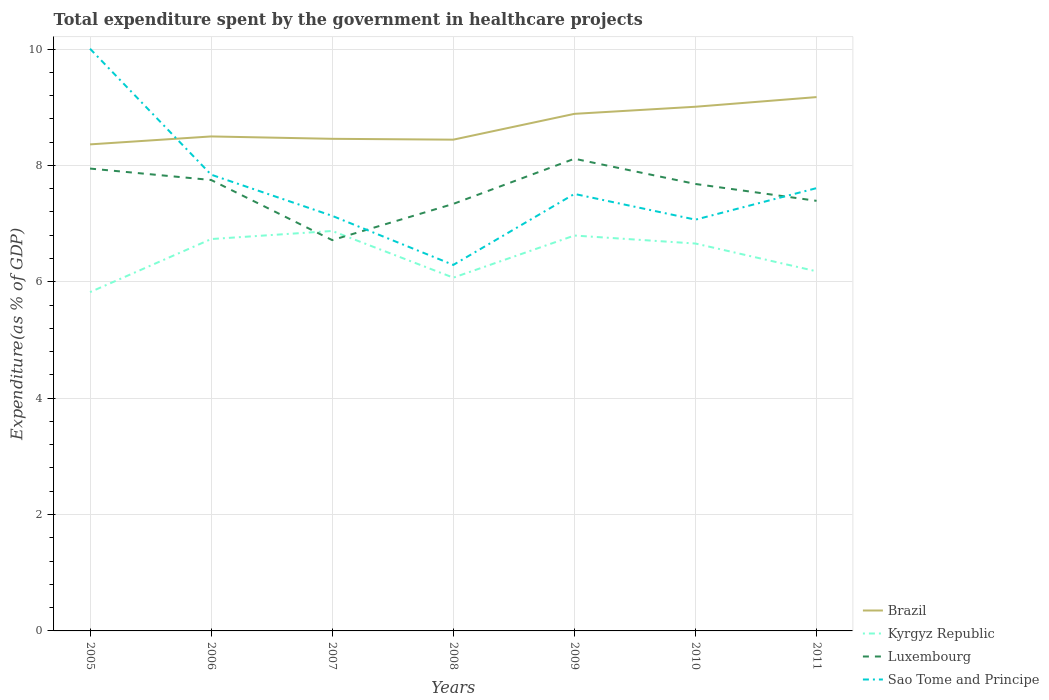Is the number of lines equal to the number of legend labels?
Offer a very short reply. Yes. Across all years, what is the maximum total expenditure spent by the government in healthcare projects in Brazil?
Offer a very short reply. 8.36. What is the total total expenditure spent by the government in healthcare projects in Luxembourg in the graph?
Make the answer very short. -0.34. What is the difference between the highest and the second highest total expenditure spent by the government in healthcare projects in Brazil?
Your answer should be compact. 0.81. What is the difference between the highest and the lowest total expenditure spent by the government in healthcare projects in Brazil?
Provide a succinct answer. 3. How many years are there in the graph?
Keep it short and to the point. 7. What is the difference between two consecutive major ticks on the Y-axis?
Offer a terse response. 2. Where does the legend appear in the graph?
Your answer should be very brief. Bottom right. How many legend labels are there?
Provide a succinct answer. 4. How are the legend labels stacked?
Provide a short and direct response. Vertical. What is the title of the graph?
Provide a short and direct response. Total expenditure spent by the government in healthcare projects. Does "Uzbekistan" appear as one of the legend labels in the graph?
Offer a very short reply. No. What is the label or title of the X-axis?
Ensure brevity in your answer.  Years. What is the label or title of the Y-axis?
Ensure brevity in your answer.  Expenditure(as % of GDP). What is the Expenditure(as % of GDP) of Brazil in 2005?
Offer a very short reply. 8.36. What is the Expenditure(as % of GDP) of Kyrgyz Republic in 2005?
Your response must be concise. 5.82. What is the Expenditure(as % of GDP) of Luxembourg in 2005?
Your answer should be compact. 7.95. What is the Expenditure(as % of GDP) in Sao Tome and Principe in 2005?
Keep it short and to the point. 10. What is the Expenditure(as % of GDP) of Brazil in 2006?
Your answer should be very brief. 8.5. What is the Expenditure(as % of GDP) in Kyrgyz Republic in 2006?
Make the answer very short. 6.73. What is the Expenditure(as % of GDP) of Luxembourg in 2006?
Offer a very short reply. 7.75. What is the Expenditure(as % of GDP) of Sao Tome and Principe in 2006?
Your response must be concise. 7.84. What is the Expenditure(as % of GDP) in Brazil in 2007?
Give a very brief answer. 8.46. What is the Expenditure(as % of GDP) of Kyrgyz Republic in 2007?
Ensure brevity in your answer.  6.87. What is the Expenditure(as % of GDP) of Luxembourg in 2007?
Offer a very short reply. 6.72. What is the Expenditure(as % of GDP) of Sao Tome and Principe in 2007?
Your answer should be compact. 7.13. What is the Expenditure(as % of GDP) of Brazil in 2008?
Provide a short and direct response. 8.44. What is the Expenditure(as % of GDP) of Kyrgyz Republic in 2008?
Offer a terse response. 6.07. What is the Expenditure(as % of GDP) of Luxembourg in 2008?
Offer a very short reply. 7.34. What is the Expenditure(as % of GDP) of Sao Tome and Principe in 2008?
Your answer should be very brief. 6.29. What is the Expenditure(as % of GDP) of Brazil in 2009?
Provide a short and direct response. 8.89. What is the Expenditure(as % of GDP) in Kyrgyz Republic in 2009?
Give a very brief answer. 6.79. What is the Expenditure(as % of GDP) of Luxembourg in 2009?
Keep it short and to the point. 8.11. What is the Expenditure(as % of GDP) of Sao Tome and Principe in 2009?
Give a very brief answer. 7.51. What is the Expenditure(as % of GDP) in Brazil in 2010?
Give a very brief answer. 9.01. What is the Expenditure(as % of GDP) of Kyrgyz Republic in 2010?
Offer a terse response. 6.66. What is the Expenditure(as % of GDP) of Luxembourg in 2010?
Give a very brief answer. 7.68. What is the Expenditure(as % of GDP) of Sao Tome and Principe in 2010?
Your response must be concise. 7.07. What is the Expenditure(as % of GDP) of Brazil in 2011?
Provide a succinct answer. 9.17. What is the Expenditure(as % of GDP) of Kyrgyz Republic in 2011?
Give a very brief answer. 6.18. What is the Expenditure(as % of GDP) of Luxembourg in 2011?
Your response must be concise. 7.39. What is the Expenditure(as % of GDP) of Sao Tome and Principe in 2011?
Make the answer very short. 7.61. Across all years, what is the maximum Expenditure(as % of GDP) in Brazil?
Offer a terse response. 9.17. Across all years, what is the maximum Expenditure(as % of GDP) in Kyrgyz Republic?
Your response must be concise. 6.87. Across all years, what is the maximum Expenditure(as % of GDP) in Luxembourg?
Make the answer very short. 8.11. Across all years, what is the maximum Expenditure(as % of GDP) in Sao Tome and Principe?
Your answer should be very brief. 10. Across all years, what is the minimum Expenditure(as % of GDP) in Brazil?
Make the answer very short. 8.36. Across all years, what is the minimum Expenditure(as % of GDP) in Kyrgyz Republic?
Your answer should be compact. 5.82. Across all years, what is the minimum Expenditure(as % of GDP) in Luxembourg?
Make the answer very short. 6.72. Across all years, what is the minimum Expenditure(as % of GDP) in Sao Tome and Principe?
Offer a terse response. 6.29. What is the total Expenditure(as % of GDP) in Brazil in the graph?
Offer a terse response. 60.83. What is the total Expenditure(as % of GDP) of Kyrgyz Republic in the graph?
Ensure brevity in your answer.  45.13. What is the total Expenditure(as % of GDP) in Luxembourg in the graph?
Your answer should be compact. 52.94. What is the total Expenditure(as % of GDP) of Sao Tome and Principe in the graph?
Offer a terse response. 53.46. What is the difference between the Expenditure(as % of GDP) of Brazil in 2005 and that in 2006?
Provide a short and direct response. -0.14. What is the difference between the Expenditure(as % of GDP) in Kyrgyz Republic in 2005 and that in 2006?
Ensure brevity in your answer.  -0.91. What is the difference between the Expenditure(as % of GDP) in Luxembourg in 2005 and that in 2006?
Your answer should be compact. 0.2. What is the difference between the Expenditure(as % of GDP) of Sao Tome and Principe in 2005 and that in 2006?
Offer a very short reply. 2.16. What is the difference between the Expenditure(as % of GDP) of Brazil in 2005 and that in 2007?
Ensure brevity in your answer.  -0.1. What is the difference between the Expenditure(as % of GDP) of Kyrgyz Republic in 2005 and that in 2007?
Offer a very short reply. -1.05. What is the difference between the Expenditure(as % of GDP) of Luxembourg in 2005 and that in 2007?
Offer a very short reply. 1.23. What is the difference between the Expenditure(as % of GDP) in Sao Tome and Principe in 2005 and that in 2007?
Provide a short and direct response. 2.87. What is the difference between the Expenditure(as % of GDP) in Brazil in 2005 and that in 2008?
Ensure brevity in your answer.  -0.08. What is the difference between the Expenditure(as % of GDP) of Kyrgyz Republic in 2005 and that in 2008?
Offer a very short reply. -0.25. What is the difference between the Expenditure(as % of GDP) of Luxembourg in 2005 and that in 2008?
Offer a very short reply. 0.61. What is the difference between the Expenditure(as % of GDP) of Sao Tome and Principe in 2005 and that in 2008?
Offer a very short reply. 3.71. What is the difference between the Expenditure(as % of GDP) in Brazil in 2005 and that in 2009?
Provide a short and direct response. -0.52. What is the difference between the Expenditure(as % of GDP) of Kyrgyz Republic in 2005 and that in 2009?
Your answer should be very brief. -0.97. What is the difference between the Expenditure(as % of GDP) of Luxembourg in 2005 and that in 2009?
Provide a short and direct response. -0.17. What is the difference between the Expenditure(as % of GDP) in Sao Tome and Principe in 2005 and that in 2009?
Offer a very short reply. 2.5. What is the difference between the Expenditure(as % of GDP) of Brazil in 2005 and that in 2010?
Offer a terse response. -0.65. What is the difference between the Expenditure(as % of GDP) of Kyrgyz Republic in 2005 and that in 2010?
Provide a short and direct response. -0.83. What is the difference between the Expenditure(as % of GDP) in Luxembourg in 2005 and that in 2010?
Your answer should be very brief. 0.26. What is the difference between the Expenditure(as % of GDP) in Sao Tome and Principe in 2005 and that in 2010?
Your answer should be very brief. 2.94. What is the difference between the Expenditure(as % of GDP) in Brazil in 2005 and that in 2011?
Provide a succinct answer. -0.81. What is the difference between the Expenditure(as % of GDP) of Kyrgyz Republic in 2005 and that in 2011?
Make the answer very short. -0.36. What is the difference between the Expenditure(as % of GDP) in Luxembourg in 2005 and that in 2011?
Provide a succinct answer. 0.55. What is the difference between the Expenditure(as % of GDP) in Sao Tome and Principe in 2005 and that in 2011?
Keep it short and to the point. 2.4. What is the difference between the Expenditure(as % of GDP) in Brazil in 2006 and that in 2007?
Make the answer very short. 0.04. What is the difference between the Expenditure(as % of GDP) in Kyrgyz Republic in 2006 and that in 2007?
Make the answer very short. -0.14. What is the difference between the Expenditure(as % of GDP) in Luxembourg in 2006 and that in 2007?
Offer a very short reply. 1.03. What is the difference between the Expenditure(as % of GDP) of Sao Tome and Principe in 2006 and that in 2007?
Provide a succinct answer. 0.71. What is the difference between the Expenditure(as % of GDP) in Brazil in 2006 and that in 2008?
Keep it short and to the point. 0.06. What is the difference between the Expenditure(as % of GDP) in Kyrgyz Republic in 2006 and that in 2008?
Provide a succinct answer. 0.66. What is the difference between the Expenditure(as % of GDP) in Luxembourg in 2006 and that in 2008?
Your answer should be very brief. 0.41. What is the difference between the Expenditure(as % of GDP) of Sao Tome and Principe in 2006 and that in 2008?
Your response must be concise. 1.55. What is the difference between the Expenditure(as % of GDP) in Brazil in 2006 and that in 2009?
Provide a succinct answer. -0.39. What is the difference between the Expenditure(as % of GDP) of Kyrgyz Republic in 2006 and that in 2009?
Your answer should be very brief. -0.06. What is the difference between the Expenditure(as % of GDP) of Luxembourg in 2006 and that in 2009?
Make the answer very short. -0.37. What is the difference between the Expenditure(as % of GDP) in Sao Tome and Principe in 2006 and that in 2009?
Provide a succinct answer. 0.33. What is the difference between the Expenditure(as % of GDP) of Brazil in 2006 and that in 2010?
Make the answer very short. -0.51. What is the difference between the Expenditure(as % of GDP) in Kyrgyz Republic in 2006 and that in 2010?
Ensure brevity in your answer.  0.08. What is the difference between the Expenditure(as % of GDP) of Luxembourg in 2006 and that in 2010?
Offer a terse response. 0.07. What is the difference between the Expenditure(as % of GDP) in Sao Tome and Principe in 2006 and that in 2010?
Your answer should be very brief. 0.77. What is the difference between the Expenditure(as % of GDP) in Brazil in 2006 and that in 2011?
Ensure brevity in your answer.  -0.68. What is the difference between the Expenditure(as % of GDP) in Kyrgyz Republic in 2006 and that in 2011?
Ensure brevity in your answer.  0.55. What is the difference between the Expenditure(as % of GDP) of Luxembourg in 2006 and that in 2011?
Offer a terse response. 0.36. What is the difference between the Expenditure(as % of GDP) of Sao Tome and Principe in 2006 and that in 2011?
Make the answer very short. 0.23. What is the difference between the Expenditure(as % of GDP) of Brazil in 2007 and that in 2008?
Provide a short and direct response. 0.01. What is the difference between the Expenditure(as % of GDP) of Kyrgyz Republic in 2007 and that in 2008?
Offer a very short reply. 0.8. What is the difference between the Expenditure(as % of GDP) of Luxembourg in 2007 and that in 2008?
Your answer should be very brief. -0.62. What is the difference between the Expenditure(as % of GDP) of Sao Tome and Principe in 2007 and that in 2008?
Keep it short and to the point. 0.84. What is the difference between the Expenditure(as % of GDP) of Brazil in 2007 and that in 2009?
Your answer should be compact. -0.43. What is the difference between the Expenditure(as % of GDP) in Kyrgyz Republic in 2007 and that in 2009?
Offer a very short reply. 0.08. What is the difference between the Expenditure(as % of GDP) in Luxembourg in 2007 and that in 2009?
Ensure brevity in your answer.  -1.4. What is the difference between the Expenditure(as % of GDP) of Sao Tome and Principe in 2007 and that in 2009?
Your answer should be compact. -0.38. What is the difference between the Expenditure(as % of GDP) in Brazil in 2007 and that in 2010?
Give a very brief answer. -0.55. What is the difference between the Expenditure(as % of GDP) in Kyrgyz Republic in 2007 and that in 2010?
Provide a succinct answer. 0.22. What is the difference between the Expenditure(as % of GDP) in Luxembourg in 2007 and that in 2010?
Make the answer very short. -0.96. What is the difference between the Expenditure(as % of GDP) of Sao Tome and Principe in 2007 and that in 2010?
Your answer should be very brief. 0.07. What is the difference between the Expenditure(as % of GDP) of Brazil in 2007 and that in 2011?
Make the answer very short. -0.72. What is the difference between the Expenditure(as % of GDP) in Kyrgyz Republic in 2007 and that in 2011?
Your answer should be compact. 0.69. What is the difference between the Expenditure(as % of GDP) of Luxembourg in 2007 and that in 2011?
Offer a very short reply. -0.68. What is the difference between the Expenditure(as % of GDP) of Sao Tome and Principe in 2007 and that in 2011?
Your answer should be very brief. -0.48. What is the difference between the Expenditure(as % of GDP) in Brazil in 2008 and that in 2009?
Your answer should be compact. -0.44. What is the difference between the Expenditure(as % of GDP) in Kyrgyz Republic in 2008 and that in 2009?
Provide a succinct answer. -0.72. What is the difference between the Expenditure(as % of GDP) in Luxembourg in 2008 and that in 2009?
Keep it short and to the point. -0.78. What is the difference between the Expenditure(as % of GDP) in Sao Tome and Principe in 2008 and that in 2009?
Provide a succinct answer. -1.22. What is the difference between the Expenditure(as % of GDP) of Brazil in 2008 and that in 2010?
Your response must be concise. -0.57. What is the difference between the Expenditure(as % of GDP) of Kyrgyz Republic in 2008 and that in 2010?
Keep it short and to the point. -0.59. What is the difference between the Expenditure(as % of GDP) of Luxembourg in 2008 and that in 2010?
Ensure brevity in your answer.  -0.34. What is the difference between the Expenditure(as % of GDP) in Sao Tome and Principe in 2008 and that in 2010?
Offer a terse response. -0.78. What is the difference between the Expenditure(as % of GDP) in Brazil in 2008 and that in 2011?
Give a very brief answer. -0.73. What is the difference between the Expenditure(as % of GDP) of Kyrgyz Republic in 2008 and that in 2011?
Your answer should be compact. -0.11. What is the difference between the Expenditure(as % of GDP) of Luxembourg in 2008 and that in 2011?
Ensure brevity in your answer.  -0.05. What is the difference between the Expenditure(as % of GDP) in Sao Tome and Principe in 2008 and that in 2011?
Ensure brevity in your answer.  -1.32. What is the difference between the Expenditure(as % of GDP) in Brazil in 2009 and that in 2010?
Your answer should be very brief. -0.12. What is the difference between the Expenditure(as % of GDP) of Kyrgyz Republic in 2009 and that in 2010?
Your answer should be very brief. 0.14. What is the difference between the Expenditure(as % of GDP) of Luxembourg in 2009 and that in 2010?
Provide a succinct answer. 0.43. What is the difference between the Expenditure(as % of GDP) of Sao Tome and Principe in 2009 and that in 2010?
Offer a very short reply. 0.44. What is the difference between the Expenditure(as % of GDP) of Brazil in 2009 and that in 2011?
Your answer should be compact. -0.29. What is the difference between the Expenditure(as % of GDP) of Kyrgyz Republic in 2009 and that in 2011?
Provide a short and direct response. 0.62. What is the difference between the Expenditure(as % of GDP) of Luxembourg in 2009 and that in 2011?
Your response must be concise. 0.72. What is the difference between the Expenditure(as % of GDP) of Sao Tome and Principe in 2009 and that in 2011?
Offer a very short reply. -0.1. What is the difference between the Expenditure(as % of GDP) of Brazil in 2010 and that in 2011?
Provide a short and direct response. -0.17. What is the difference between the Expenditure(as % of GDP) in Kyrgyz Republic in 2010 and that in 2011?
Give a very brief answer. 0.48. What is the difference between the Expenditure(as % of GDP) in Luxembourg in 2010 and that in 2011?
Offer a terse response. 0.29. What is the difference between the Expenditure(as % of GDP) of Sao Tome and Principe in 2010 and that in 2011?
Your answer should be very brief. -0.54. What is the difference between the Expenditure(as % of GDP) in Brazil in 2005 and the Expenditure(as % of GDP) in Kyrgyz Republic in 2006?
Give a very brief answer. 1.63. What is the difference between the Expenditure(as % of GDP) of Brazil in 2005 and the Expenditure(as % of GDP) of Luxembourg in 2006?
Ensure brevity in your answer.  0.61. What is the difference between the Expenditure(as % of GDP) of Brazil in 2005 and the Expenditure(as % of GDP) of Sao Tome and Principe in 2006?
Provide a short and direct response. 0.52. What is the difference between the Expenditure(as % of GDP) in Kyrgyz Republic in 2005 and the Expenditure(as % of GDP) in Luxembourg in 2006?
Your answer should be compact. -1.93. What is the difference between the Expenditure(as % of GDP) of Kyrgyz Republic in 2005 and the Expenditure(as % of GDP) of Sao Tome and Principe in 2006?
Make the answer very short. -2.02. What is the difference between the Expenditure(as % of GDP) of Luxembourg in 2005 and the Expenditure(as % of GDP) of Sao Tome and Principe in 2006?
Give a very brief answer. 0.1. What is the difference between the Expenditure(as % of GDP) of Brazil in 2005 and the Expenditure(as % of GDP) of Kyrgyz Republic in 2007?
Give a very brief answer. 1.49. What is the difference between the Expenditure(as % of GDP) in Brazil in 2005 and the Expenditure(as % of GDP) in Luxembourg in 2007?
Your answer should be very brief. 1.65. What is the difference between the Expenditure(as % of GDP) in Brazil in 2005 and the Expenditure(as % of GDP) in Sao Tome and Principe in 2007?
Offer a terse response. 1.23. What is the difference between the Expenditure(as % of GDP) of Kyrgyz Republic in 2005 and the Expenditure(as % of GDP) of Luxembourg in 2007?
Your response must be concise. -0.89. What is the difference between the Expenditure(as % of GDP) in Kyrgyz Republic in 2005 and the Expenditure(as % of GDP) in Sao Tome and Principe in 2007?
Your response must be concise. -1.31. What is the difference between the Expenditure(as % of GDP) of Luxembourg in 2005 and the Expenditure(as % of GDP) of Sao Tome and Principe in 2007?
Keep it short and to the point. 0.81. What is the difference between the Expenditure(as % of GDP) of Brazil in 2005 and the Expenditure(as % of GDP) of Kyrgyz Republic in 2008?
Keep it short and to the point. 2.29. What is the difference between the Expenditure(as % of GDP) in Brazil in 2005 and the Expenditure(as % of GDP) in Luxembourg in 2008?
Give a very brief answer. 1.02. What is the difference between the Expenditure(as % of GDP) of Brazil in 2005 and the Expenditure(as % of GDP) of Sao Tome and Principe in 2008?
Your answer should be very brief. 2.07. What is the difference between the Expenditure(as % of GDP) of Kyrgyz Republic in 2005 and the Expenditure(as % of GDP) of Luxembourg in 2008?
Ensure brevity in your answer.  -1.52. What is the difference between the Expenditure(as % of GDP) in Kyrgyz Republic in 2005 and the Expenditure(as % of GDP) in Sao Tome and Principe in 2008?
Make the answer very short. -0.47. What is the difference between the Expenditure(as % of GDP) in Luxembourg in 2005 and the Expenditure(as % of GDP) in Sao Tome and Principe in 2008?
Provide a short and direct response. 1.66. What is the difference between the Expenditure(as % of GDP) of Brazil in 2005 and the Expenditure(as % of GDP) of Kyrgyz Republic in 2009?
Ensure brevity in your answer.  1.57. What is the difference between the Expenditure(as % of GDP) in Brazil in 2005 and the Expenditure(as % of GDP) in Luxembourg in 2009?
Ensure brevity in your answer.  0.25. What is the difference between the Expenditure(as % of GDP) of Brazil in 2005 and the Expenditure(as % of GDP) of Sao Tome and Principe in 2009?
Keep it short and to the point. 0.85. What is the difference between the Expenditure(as % of GDP) in Kyrgyz Republic in 2005 and the Expenditure(as % of GDP) in Luxembourg in 2009?
Your answer should be very brief. -2.29. What is the difference between the Expenditure(as % of GDP) in Kyrgyz Republic in 2005 and the Expenditure(as % of GDP) in Sao Tome and Principe in 2009?
Offer a very short reply. -1.69. What is the difference between the Expenditure(as % of GDP) of Luxembourg in 2005 and the Expenditure(as % of GDP) of Sao Tome and Principe in 2009?
Ensure brevity in your answer.  0.44. What is the difference between the Expenditure(as % of GDP) of Brazil in 2005 and the Expenditure(as % of GDP) of Kyrgyz Republic in 2010?
Your answer should be compact. 1.7. What is the difference between the Expenditure(as % of GDP) of Brazil in 2005 and the Expenditure(as % of GDP) of Luxembourg in 2010?
Keep it short and to the point. 0.68. What is the difference between the Expenditure(as % of GDP) in Brazil in 2005 and the Expenditure(as % of GDP) in Sao Tome and Principe in 2010?
Your answer should be very brief. 1.29. What is the difference between the Expenditure(as % of GDP) in Kyrgyz Republic in 2005 and the Expenditure(as % of GDP) in Luxembourg in 2010?
Keep it short and to the point. -1.86. What is the difference between the Expenditure(as % of GDP) of Kyrgyz Republic in 2005 and the Expenditure(as % of GDP) of Sao Tome and Principe in 2010?
Make the answer very short. -1.25. What is the difference between the Expenditure(as % of GDP) of Luxembourg in 2005 and the Expenditure(as % of GDP) of Sao Tome and Principe in 2010?
Give a very brief answer. 0.88. What is the difference between the Expenditure(as % of GDP) in Brazil in 2005 and the Expenditure(as % of GDP) in Kyrgyz Republic in 2011?
Provide a short and direct response. 2.18. What is the difference between the Expenditure(as % of GDP) of Brazil in 2005 and the Expenditure(as % of GDP) of Luxembourg in 2011?
Provide a short and direct response. 0.97. What is the difference between the Expenditure(as % of GDP) of Brazil in 2005 and the Expenditure(as % of GDP) of Sao Tome and Principe in 2011?
Provide a short and direct response. 0.75. What is the difference between the Expenditure(as % of GDP) of Kyrgyz Republic in 2005 and the Expenditure(as % of GDP) of Luxembourg in 2011?
Provide a succinct answer. -1.57. What is the difference between the Expenditure(as % of GDP) of Kyrgyz Republic in 2005 and the Expenditure(as % of GDP) of Sao Tome and Principe in 2011?
Offer a terse response. -1.79. What is the difference between the Expenditure(as % of GDP) of Luxembourg in 2005 and the Expenditure(as % of GDP) of Sao Tome and Principe in 2011?
Your answer should be compact. 0.34. What is the difference between the Expenditure(as % of GDP) of Brazil in 2006 and the Expenditure(as % of GDP) of Kyrgyz Republic in 2007?
Provide a succinct answer. 1.62. What is the difference between the Expenditure(as % of GDP) of Brazil in 2006 and the Expenditure(as % of GDP) of Luxembourg in 2007?
Offer a terse response. 1.78. What is the difference between the Expenditure(as % of GDP) of Brazil in 2006 and the Expenditure(as % of GDP) of Sao Tome and Principe in 2007?
Give a very brief answer. 1.36. What is the difference between the Expenditure(as % of GDP) of Kyrgyz Republic in 2006 and the Expenditure(as % of GDP) of Luxembourg in 2007?
Give a very brief answer. 0.02. What is the difference between the Expenditure(as % of GDP) in Kyrgyz Republic in 2006 and the Expenditure(as % of GDP) in Sao Tome and Principe in 2007?
Offer a very short reply. -0.4. What is the difference between the Expenditure(as % of GDP) in Luxembourg in 2006 and the Expenditure(as % of GDP) in Sao Tome and Principe in 2007?
Provide a short and direct response. 0.62. What is the difference between the Expenditure(as % of GDP) of Brazil in 2006 and the Expenditure(as % of GDP) of Kyrgyz Republic in 2008?
Give a very brief answer. 2.43. What is the difference between the Expenditure(as % of GDP) of Brazil in 2006 and the Expenditure(as % of GDP) of Luxembourg in 2008?
Your answer should be very brief. 1.16. What is the difference between the Expenditure(as % of GDP) in Brazil in 2006 and the Expenditure(as % of GDP) in Sao Tome and Principe in 2008?
Offer a very short reply. 2.21. What is the difference between the Expenditure(as % of GDP) in Kyrgyz Republic in 2006 and the Expenditure(as % of GDP) in Luxembourg in 2008?
Keep it short and to the point. -0.6. What is the difference between the Expenditure(as % of GDP) in Kyrgyz Republic in 2006 and the Expenditure(as % of GDP) in Sao Tome and Principe in 2008?
Provide a succinct answer. 0.44. What is the difference between the Expenditure(as % of GDP) in Luxembourg in 2006 and the Expenditure(as % of GDP) in Sao Tome and Principe in 2008?
Make the answer very short. 1.46. What is the difference between the Expenditure(as % of GDP) in Brazil in 2006 and the Expenditure(as % of GDP) in Kyrgyz Republic in 2009?
Keep it short and to the point. 1.7. What is the difference between the Expenditure(as % of GDP) in Brazil in 2006 and the Expenditure(as % of GDP) in Luxembourg in 2009?
Make the answer very short. 0.38. What is the difference between the Expenditure(as % of GDP) of Brazil in 2006 and the Expenditure(as % of GDP) of Sao Tome and Principe in 2009?
Your answer should be compact. 0.99. What is the difference between the Expenditure(as % of GDP) of Kyrgyz Republic in 2006 and the Expenditure(as % of GDP) of Luxembourg in 2009?
Make the answer very short. -1.38. What is the difference between the Expenditure(as % of GDP) in Kyrgyz Republic in 2006 and the Expenditure(as % of GDP) in Sao Tome and Principe in 2009?
Ensure brevity in your answer.  -0.78. What is the difference between the Expenditure(as % of GDP) of Luxembourg in 2006 and the Expenditure(as % of GDP) of Sao Tome and Principe in 2009?
Provide a succinct answer. 0.24. What is the difference between the Expenditure(as % of GDP) in Brazil in 2006 and the Expenditure(as % of GDP) in Kyrgyz Republic in 2010?
Make the answer very short. 1.84. What is the difference between the Expenditure(as % of GDP) of Brazil in 2006 and the Expenditure(as % of GDP) of Luxembourg in 2010?
Ensure brevity in your answer.  0.82. What is the difference between the Expenditure(as % of GDP) in Brazil in 2006 and the Expenditure(as % of GDP) in Sao Tome and Principe in 2010?
Offer a terse response. 1.43. What is the difference between the Expenditure(as % of GDP) in Kyrgyz Republic in 2006 and the Expenditure(as % of GDP) in Luxembourg in 2010?
Keep it short and to the point. -0.95. What is the difference between the Expenditure(as % of GDP) of Kyrgyz Republic in 2006 and the Expenditure(as % of GDP) of Sao Tome and Principe in 2010?
Give a very brief answer. -0.33. What is the difference between the Expenditure(as % of GDP) in Luxembourg in 2006 and the Expenditure(as % of GDP) in Sao Tome and Principe in 2010?
Keep it short and to the point. 0.68. What is the difference between the Expenditure(as % of GDP) in Brazil in 2006 and the Expenditure(as % of GDP) in Kyrgyz Republic in 2011?
Provide a succinct answer. 2.32. What is the difference between the Expenditure(as % of GDP) of Brazil in 2006 and the Expenditure(as % of GDP) of Luxembourg in 2011?
Make the answer very short. 1.11. What is the difference between the Expenditure(as % of GDP) in Brazil in 2006 and the Expenditure(as % of GDP) in Sao Tome and Principe in 2011?
Make the answer very short. 0.89. What is the difference between the Expenditure(as % of GDP) in Kyrgyz Republic in 2006 and the Expenditure(as % of GDP) in Luxembourg in 2011?
Ensure brevity in your answer.  -0.66. What is the difference between the Expenditure(as % of GDP) in Kyrgyz Republic in 2006 and the Expenditure(as % of GDP) in Sao Tome and Principe in 2011?
Your answer should be very brief. -0.88. What is the difference between the Expenditure(as % of GDP) in Luxembourg in 2006 and the Expenditure(as % of GDP) in Sao Tome and Principe in 2011?
Your response must be concise. 0.14. What is the difference between the Expenditure(as % of GDP) of Brazil in 2007 and the Expenditure(as % of GDP) of Kyrgyz Republic in 2008?
Keep it short and to the point. 2.39. What is the difference between the Expenditure(as % of GDP) of Brazil in 2007 and the Expenditure(as % of GDP) of Luxembourg in 2008?
Provide a succinct answer. 1.12. What is the difference between the Expenditure(as % of GDP) of Brazil in 2007 and the Expenditure(as % of GDP) of Sao Tome and Principe in 2008?
Offer a very short reply. 2.17. What is the difference between the Expenditure(as % of GDP) of Kyrgyz Republic in 2007 and the Expenditure(as % of GDP) of Luxembourg in 2008?
Your answer should be very brief. -0.47. What is the difference between the Expenditure(as % of GDP) in Kyrgyz Republic in 2007 and the Expenditure(as % of GDP) in Sao Tome and Principe in 2008?
Provide a short and direct response. 0.58. What is the difference between the Expenditure(as % of GDP) in Luxembourg in 2007 and the Expenditure(as % of GDP) in Sao Tome and Principe in 2008?
Provide a succinct answer. 0.43. What is the difference between the Expenditure(as % of GDP) in Brazil in 2007 and the Expenditure(as % of GDP) in Kyrgyz Republic in 2009?
Make the answer very short. 1.66. What is the difference between the Expenditure(as % of GDP) of Brazil in 2007 and the Expenditure(as % of GDP) of Luxembourg in 2009?
Keep it short and to the point. 0.34. What is the difference between the Expenditure(as % of GDP) in Brazil in 2007 and the Expenditure(as % of GDP) in Sao Tome and Principe in 2009?
Your answer should be very brief. 0.95. What is the difference between the Expenditure(as % of GDP) in Kyrgyz Republic in 2007 and the Expenditure(as % of GDP) in Luxembourg in 2009?
Provide a succinct answer. -1.24. What is the difference between the Expenditure(as % of GDP) of Kyrgyz Republic in 2007 and the Expenditure(as % of GDP) of Sao Tome and Principe in 2009?
Provide a short and direct response. -0.64. What is the difference between the Expenditure(as % of GDP) of Luxembourg in 2007 and the Expenditure(as % of GDP) of Sao Tome and Principe in 2009?
Keep it short and to the point. -0.79. What is the difference between the Expenditure(as % of GDP) of Brazil in 2007 and the Expenditure(as % of GDP) of Kyrgyz Republic in 2010?
Make the answer very short. 1.8. What is the difference between the Expenditure(as % of GDP) of Brazil in 2007 and the Expenditure(as % of GDP) of Luxembourg in 2010?
Keep it short and to the point. 0.78. What is the difference between the Expenditure(as % of GDP) of Brazil in 2007 and the Expenditure(as % of GDP) of Sao Tome and Principe in 2010?
Keep it short and to the point. 1.39. What is the difference between the Expenditure(as % of GDP) of Kyrgyz Republic in 2007 and the Expenditure(as % of GDP) of Luxembourg in 2010?
Ensure brevity in your answer.  -0.81. What is the difference between the Expenditure(as % of GDP) in Kyrgyz Republic in 2007 and the Expenditure(as % of GDP) in Sao Tome and Principe in 2010?
Offer a terse response. -0.19. What is the difference between the Expenditure(as % of GDP) in Luxembourg in 2007 and the Expenditure(as % of GDP) in Sao Tome and Principe in 2010?
Your answer should be compact. -0.35. What is the difference between the Expenditure(as % of GDP) of Brazil in 2007 and the Expenditure(as % of GDP) of Kyrgyz Republic in 2011?
Offer a terse response. 2.28. What is the difference between the Expenditure(as % of GDP) of Brazil in 2007 and the Expenditure(as % of GDP) of Luxembourg in 2011?
Ensure brevity in your answer.  1.07. What is the difference between the Expenditure(as % of GDP) in Brazil in 2007 and the Expenditure(as % of GDP) in Sao Tome and Principe in 2011?
Make the answer very short. 0.85. What is the difference between the Expenditure(as % of GDP) in Kyrgyz Republic in 2007 and the Expenditure(as % of GDP) in Luxembourg in 2011?
Provide a succinct answer. -0.52. What is the difference between the Expenditure(as % of GDP) of Kyrgyz Republic in 2007 and the Expenditure(as % of GDP) of Sao Tome and Principe in 2011?
Your answer should be compact. -0.74. What is the difference between the Expenditure(as % of GDP) in Luxembourg in 2007 and the Expenditure(as % of GDP) in Sao Tome and Principe in 2011?
Provide a short and direct response. -0.89. What is the difference between the Expenditure(as % of GDP) in Brazil in 2008 and the Expenditure(as % of GDP) in Kyrgyz Republic in 2009?
Offer a terse response. 1.65. What is the difference between the Expenditure(as % of GDP) in Brazil in 2008 and the Expenditure(as % of GDP) in Luxembourg in 2009?
Your answer should be very brief. 0.33. What is the difference between the Expenditure(as % of GDP) of Brazil in 2008 and the Expenditure(as % of GDP) of Sao Tome and Principe in 2009?
Provide a short and direct response. 0.93. What is the difference between the Expenditure(as % of GDP) in Kyrgyz Republic in 2008 and the Expenditure(as % of GDP) in Luxembourg in 2009?
Provide a succinct answer. -2.04. What is the difference between the Expenditure(as % of GDP) in Kyrgyz Republic in 2008 and the Expenditure(as % of GDP) in Sao Tome and Principe in 2009?
Your answer should be very brief. -1.44. What is the difference between the Expenditure(as % of GDP) in Luxembourg in 2008 and the Expenditure(as % of GDP) in Sao Tome and Principe in 2009?
Give a very brief answer. -0.17. What is the difference between the Expenditure(as % of GDP) in Brazil in 2008 and the Expenditure(as % of GDP) in Kyrgyz Republic in 2010?
Provide a succinct answer. 1.79. What is the difference between the Expenditure(as % of GDP) in Brazil in 2008 and the Expenditure(as % of GDP) in Luxembourg in 2010?
Offer a very short reply. 0.76. What is the difference between the Expenditure(as % of GDP) of Brazil in 2008 and the Expenditure(as % of GDP) of Sao Tome and Principe in 2010?
Ensure brevity in your answer.  1.37. What is the difference between the Expenditure(as % of GDP) of Kyrgyz Republic in 2008 and the Expenditure(as % of GDP) of Luxembourg in 2010?
Your response must be concise. -1.61. What is the difference between the Expenditure(as % of GDP) in Kyrgyz Republic in 2008 and the Expenditure(as % of GDP) in Sao Tome and Principe in 2010?
Offer a very short reply. -1. What is the difference between the Expenditure(as % of GDP) of Luxembourg in 2008 and the Expenditure(as % of GDP) of Sao Tome and Principe in 2010?
Make the answer very short. 0.27. What is the difference between the Expenditure(as % of GDP) of Brazil in 2008 and the Expenditure(as % of GDP) of Kyrgyz Republic in 2011?
Give a very brief answer. 2.26. What is the difference between the Expenditure(as % of GDP) in Brazil in 2008 and the Expenditure(as % of GDP) in Luxembourg in 2011?
Your response must be concise. 1.05. What is the difference between the Expenditure(as % of GDP) of Brazil in 2008 and the Expenditure(as % of GDP) of Sao Tome and Principe in 2011?
Your response must be concise. 0.83. What is the difference between the Expenditure(as % of GDP) of Kyrgyz Republic in 2008 and the Expenditure(as % of GDP) of Luxembourg in 2011?
Ensure brevity in your answer.  -1.32. What is the difference between the Expenditure(as % of GDP) of Kyrgyz Republic in 2008 and the Expenditure(as % of GDP) of Sao Tome and Principe in 2011?
Offer a very short reply. -1.54. What is the difference between the Expenditure(as % of GDP) of Luxembourg in 2008 and the Expenditure(as % of GDP) of Sao Tome and Principe in 2011?
Offer a terse response. -0.27. What is the difference between the Expenditure(as % of GDP) of Brazil in 2009 and the Expenditure(as % of GDP) of Kyrgyz Republic in 2010?
Provide a short and direct response. 2.23. What is the difference between the Expenditure(as % of GDP) in Brazil in 2009 and the Expenditure(as % of GDP) in Luxembourg in 2010?
Ensure brevity in your answer.  1.21. What is the difference between the Expenditure(as % of GDP) in Brazil in 2009 and the Expenditure(as % of GDP) in Sao Tome and Principe in 2010?
Ensure brevity in your answer.  1.82. What is the difference between the Expenditure(as % of GDP) of Kyrgyz Republic in 2009 and the Expenditure(as % of GDP) of Luxembourg in 2010?
Offer a terse response. -0.89. What is the difference between the Expenditure(as % of GDP) of Kyrgyz Republic in 2009 and the Expenditure(as % of GDP) of Sao Tome and Principe in 2010?
Your answer should be compact. -0.27. What is the difference between the Expenditure(as % of GDP) of Luxembourg in 2009 and the Expenditure(as % of GDP) of Sao Tome and Principe in 2010?
Give a very brief answer. 1.05. What is the difference between the Expenditure(as % of GDP) in Brazil in 2009 and the Expenditure(as % of GDP) in Kyrgyz Republic in 2011?
Offer a very short reply. 2.71. What is the difference between the Expenditure(as % of GDP) in Brazil in 2009 and the Expenditure(as % of GDP) in Luxembourg in 2011?
Make the answer very short. 1.49. What is the difference between the Expenditure(as % of GDP) of Brazil in 2009 and the Expenditure(as % of GDP) of Sao Tome and Principe in 2011?
Your response must be concise. 1.28. What is the difference between the Expenditure(as % of GDP) of Kyrgyz Republic in 2009 and the Expenditure(as % of GDP) of Luxembourg in 2011?
Give a very brief answer. -0.6. What is the difference between the Expenditure(as % of GDP) in Kyrgyz Republic in 2009 and the Expenditure(as % of GDP) in Sao Tome and Principe in 2011?
Provide a short and direct response. -0.81. What is the difference between the Expenditure(as % of GDP) of Luxembourg in 2009 and the Expenditure(as % of GDP) of Sao Tome and Principe in 2011?
Make the answer very short. 0.5. What is the difference between the Expenditure(as % of GDP) in Brazil in 2010 and the Expenditure(as % of GDP) in Kyrgyz Republic in 2011?
Offer a terse response. 2.83. What is the difference between the Expenditure(as % of GDP) in Brazil in 2010 and the Expenditure(as % of GDP) in Luxembourg in 2011?
Provide a short and direct response. 1.62. What is the difference between the Expenditure(as % of GDP) in Brazil in 2010 and the Expenditure(as % of GDP) in Sao Tome and Principe in 2011?
Offer a terse response. 1.4. What is the difference between the Expenditure(as % of GDP) in Kyrgyz Republic in 2010 and the Expenditure(as % of GDP) in Luxembourg in 2011?
Give a very brief answer. -0.73. What is the difference between the Expenditure(as % of GDP) in Kyrgyz Republic in 2010 and the Expenditure(as % of GDP) in Sao Tome and Principe in 2011?
Keep it short and to the point. -0.95. What is the difference between the Expenditure(as % of GDP) in Luxembourg in 2010 and the Expenditure(as % of GDP) in Sao Tome and Principe in 2011?
Offer a very short reply. 0.07. What is the average Expenditure(as % of GDP) in Brazil per year?
Your answer should be very brief. 8.69. What is the average Expenditure(as % of GDP) in Kyrgyz Republic per year?
Your response must be concise. 6.45. What is the average Expenditure(as % of GDP) of Luxembourg per year?
Offer a terse response. 7.56. What is the average Expenditure(as % of GDP) of Sao Tome and Principe per year?
Give a very brief answer. 7.64. In the year 2005, what is the difference between the Expenditure(as % of GDP) of Brazil and Expenditure(as % of GDP) of Kyrgyz Republic?
Your answer should be compact. 2.54. In the year 2005, what is the difference between the Expenditure(as % of GDP) of Brazil and Expenditure(as % of GDP) of Luxembourg?
Keep it short and to the point. 0.42. In the year 2005, what is the difference between the Expenditure(as % of GDP) of Brazil and Expenditure(as % of GDP) of Sao Tome and Principe?
Your answer should be compact. -1.64. In the year 2005, what is the difference between the Expenditure(as % of GDP) of Kyrgyz Republic and Expenditure(as % of GDP) of Luxembourg?
Make the answer very short. -2.12. In the year 2005, what is the difference between the Expenditure(as % of GDP) of Kyrgyz Republic and Expenditure(as % of GDP) of Sao Tome and Principe?
Make the answer very short. -4.18. In the year 2005, what is the difference between the Expenditure(as % of GDP) of Luxembourg and Expenditure(as % of GDP) of Sao Tome and Principe?
Offer a terse response. -2.06. In the year 2006, what is the difference between the Expenditure(as % of GDP) of Brazil and Expenditure(as % of GDP) of Kyrgyz Republic?
Give a very brief answer. 1.76. In the year 2006, what is the difference between the Expenditure(as % of GDP) in Brazil and Expenditure(as % of GDP) in Luxembourg?
Offer a terse response. 0.75. In the year 2006, what is the difference between the Expenditure(as % of GDP) in Brazil and Expenditure(as % of GDP) in Sao Tome and Principe?
Your response must be concise. 0.66. In the year 2006, what is the difference between the Expenditure(as % of GDP) of Kyrgyz Republic and Expenditure(as % of GDP) of Luxembourg?
Provide a short and direct response. -1.02. In the year 2006, what is the difference between the Expenditure(as % of GDP) in Kyrgyz Republic and Expenditure(as % of GDP) in Sao Tome and Principe?
Your answer should be very brief. -1.11. In the year 2006, what is the difference between the Expenditure(as % of GDP) of Luxembourg and Expenditure(as % of GDP) of Sao Tome and Principe?
Make the answer very short. -0.09. In the year 2007, what is the difference between the Expenditure(as % of GDP) of Brazil and Expenditure(as % of GDP) of Kyrgyz Republic?
Make the answer very short. 1.58. In the year 2007, what is the difference between the Expenditure(as % of GDP) in Brazil and Expenditure(as % of GDP) in Luxembourg?
Offer a very short reply. 1.74. In the year 2007, what is the difference between the Expenditure(as % of GDP) of Brazil and Expenditure(as % of GDP) of Sao Tome and Principe?
Your response must be concise. 1.32. In the year 2007, what is the difference between the Expenditure(as % of GDP) of Kyrgyz Republic and Expenditure(as % of GDP) of Luxembourg?
Keep it short and to the point. 0.16. In the year 2007, what is the difference between the Expenditure(as % of GDP) of Kyrgyz Republic and Expenditure(as % of GDP) of Sao Tome and Principe?
Your response must be concise. -0.26. In the year 2007, what is the difference between the Expenditure(as % of GDP) in Luxembourg and Expenditure(as % of GDP) in Sao Tome and Principe?
Offer a very short reply. -0.42. In the year 2008, what is the difference between the Expenditure(as % of GDP) of Brazil and Expenditure(as % of GDP) of Kyrgyz Republic?
Provide a succinct answer. 2.37. In the year 2008, what is the difference between the Expenditure(as % of GDP) in Brazil and Expenditure(as % of GDP) in Luxembourg?
Keep it short and to the point. 1.1. In the year 2008, what is the difference between the Expenditure(as % of GDP) in Brazil and Expenditure(as % of GDP) in Sao Tome and Principe?
Provide a succinct answer. 2.15. In the year 2008, what is the difference between the Expenditure(as % of GDP) in Kyrgyz Republic and Expenditure(as % of GDP) in Luxembourg?
Your answer should be very brief. -1.27. In the year 2008, what is the difference between the Expenditure(as % of GDP) in Kyrgyz Republic and Expenditure(as % of GDP) in Sao Tome and Principe?
Your answer should be very brief. -0.22. In the year 2008, what is the difference between the Expenditure(as % of GDP) in Luxembourg and Expenditure(as % of GDP) in Sao Tome and Principe?
Provide a short and direct response. 1.05. In the year 2009, what is the difference between the Expenditure(as % of GDP) of Brazil and Expenditure(as % of GDP) of Kyrgyz Republic?
Your answer should be compact. 2.09. In the year 2009, what is the difference between the Expenditure(as % of GDP) of Brazil and Expenditure(as % of GDP) of Luxembourg?
Make the answer very short. 0.77. In the year 2009, what is the difference between the Expenditure(as % of GDP) of Brazil and Expenditure(as % of GDP) of Sao Tome and Principe?
Make the answer very short. 1.38. In the year 2009, what is the difference between the Expenditure(as % of GDP) of Kyrgyz Republic and Expenditure(as % of GDP) of Luxembourg?
Give a very brief answer. -1.32. In the year 2009, what is the difference between the Expenditure(as % of GDP) of Kyrgyz Republic and Expenditure(as % of GDP) of Sao Tome and Principe?
Provide a succinct answer. -0.71. In the year 2009, what is the difference between the Expenditure(as % of GDP) of Luxembourg and Expenditure(as % of GDP) of Sao Tome and Principe?
Give a very brief answer. 0.6. In the year 2010, what is the difference between the Expenditure(as % of GDP) of Brazil and Expenditure(as % of GDP) of Kyrgyz Republic?
Offer a very short reply. 2.35. In the year 2010, what is the difference between the Expenditure(as % of GDP) of Brazil and Expenditure(as % of GDP) of Luxembourg?
Your answer should be very brief. 1.33. In the year 2010, what is the difference between the Expenditure(as % of GDP) of Brazil and Expenditure(as % of GDP) of Sao Tome and Principe?
Provide a succinct answer. 1.94. In the year 2010, what is the difference between the Expenditure(as % of GDP) in Kyrgyz Republic and Expenditure(as % of GDP) in Luxembourg?
Your answer should be very brief. -1.02. In the year 2010, what is the difference between the Expenditure(as % of GDP) of Kyrgyz Republic and Expenditure(as % of GDP) of Sao Tome and Principe?
Give a very brief answer. -0.41. In the year 2010, what is the difference between the Expenditure(as % of GDP) of Luxembourg and Expenditure(as % of GDP) of Sao Tome and Principe?
Make the answer very short. 0.61. In the year 2011, what is the difference between the Expenditure(as % of GDP) of Brazil and Expenditure(as % of GDP) of Kyrgyz Republic?
Give a very brief answer. 2.99. In the year 2011, what is the difference between the Expenditure(as % of GDP) in Brazil and Expenditure(as % of GDP) in Luxembourg?
Your answer should be compact. 1.78. In the year 2011, what is the difference between the Expenditure(as % of GDP) of Brazil and Expenditure(as % of GDP) of Sao Tome and Principe?
Provide a succinct answer. 1.56. In the year 2011, what is the difference between the Expenditure(as % of GDP) in Kyrgyz Republic and Expenditure(as % of GDP) in Luxembourg?
Keep it short and to the point. -1.21. In the year 2011, what is the difference between the Expenditure(as % of GDP) of Kyrgyz Republic and Expenditure(as % of GDP) of Sao Tome and Principe?
Make the answer very short. -1.43. In the year 2011, what is the difference between the Expenditure(as % of GDP) in Luxembourg and Expenditure(as % of GDP) in Sao Tome and Principe?
Your answer should be compact. -0.22. What is the ratio of the Expenditure(as % of GDP) in Brazil in 2005 to that in 2006?
Offer a terse response. 0.98. What is the ratio of the Expenditure(as % of GDP) in Kyrgyz Republic in 2005 to that in 2006?
Your response must be concise. 0.86. What is the ratio of the Expenditure(as % of GDP) of Luxembourg in 2005 to that in 2006?
Your answer should be compact. 1.03. What is the ratio of the Expenditure(as % of GDP) in Sao Tome and Principe in 2005 to that in 2006?
Offer a very short reply. 1.28. What is the ratio of the Expenditure(as % of GDP) of Brazil in 2005 to that in 2007?
Provide a short and direct response. 0.99. What is the ratio of the Expenditure(as % of GDP) of Kyrgyz Republic in 2005 to that in 2007?
Provide a short and direct response. 0.85. What is the ratio of the Expenditure(as % of GDP) of Luxembourg in 2005 to that in 2007?
Keep it short and to the point. 1.18. What is the ratio of the Expenditure(as % of GDP) of Sao Tome and Principe in 2005 to that in 2007?
Ensure brevity in your answer.  1.4. What is the ratio of the Expenditure(as % of GDP) of Luxembourg in 2005 to that in 2008?
Your answer should be compact. 1.08. What is the ratio of the Expenditure(as % of GDP) in Sao Tome and Principe in 2005 to that in 2008?
Your answer should be compact. 1.59. What is the ratio of the Expenditure(as % of GDP) of Brazil in 2005 to that in 2009?
Give a very brief answer. 0.94. What is the ratio of the Expenditure(as % of GDP) in Kyrgyz Republic in 2005 to that in 2009?
Ensure brevity in your answer.  0.86. What is the ratio of the Expenditure(as % of GDP) of Luxembourg in 2005 to that in 2009?
Offer a terse response. 0.98. What is the ratio of the Expenditure(as % of GDP) in Sao Tome and Principe in 2005 to that in 2009?
Give a very brief answer. 1.33. What is the ratio of the Expenditure(as % of GDP) in Brazil in 2005 to that in 2010?
Your response must be concise. 0.93. What is the ratio of the Expenditure(as % of GDP) of Kyrgyz Republic in 2005 to that in 2010?
Keep it short and to the point. 0.87. What is the ratio of the Expenditure(as % of GDP) of Luxembourg in 2005 to that in 2010?
Ensure brevity in your answer.  1.03. What is the ratio of the Expenditure(as % of GDP) in Sao Tome and Principe in 2005 to that in 2010?
Make the answer very short. 1.42. What is the ratio of the Expenditure(as % of GDP) of Brazil in 2005 to that in 2011?
Offer a terse response. 0.91. What is the ratio of the Expenditure(as % of GDP) in Kyrgyz Republic in 2005 to that in 2011?
Make the answer very short. 0.94. What is the ratio of the Expenditure(as % of GDP) in Luxembourg in 2005 to that in 2011?
Provide a succinct answer. 1.07. What is the ratio of the Expenditure(as % of GDP) of Sao Tome and Principe in 2005 to that in 2011?
Your answer should be compact. 1.31. What is the ratio of the Expenditure(as % of GDP) in Kyrgyz Republic in 2006 to that in 2007?
Keep it short and to the point. 0.98. What is the ratio of the Expenditure(as % of GDP) of Luxembourg in 2006 to that in 2007?
Your answer should be very brief. 1.15. What is the ratio of the Expenditure(as % of GDP) in Sao Tome and Principe in 2006 to that in 2007?
Your answer should be compact. 1.1. What is the ratio of the Expenditure(as % of GDP) in Brazil in 2006 to that in 2008?
Provide a succinct answer. 1.01. What is the ratio of the Expenditure(as % of GDP) of Kyrgyz Republic in 2006 to that in 2008?
Keep it short and to the point. 1.11. What is the ratio of the Expenditure(as % of GDP) of Luxembourg in 2006 to that in 2008?
Your response must be concise. 1.06. What is the ratio of the Expenditure(as % of GDP) of Sao Tome and Principe in 2006 to that in 2008?
Your answer should be very brief. 1.25. What is the ratio of the Expenditure(as % of GDP) in Brazil in 2006 to that in 2009?
Make the answer very short. 0.96. What is the ratio of the Expenditure(as % of GDP) in Kyrgyz Republic in 2006 to that in 2009?
Provide a short and direct response. 0.99. What is the ratio of the Expenditure(as % of GDP) in Luxembourg in 2006 to that in 2009?
Ensure brevity in your answer.  0.95. What is the ratio of the Expenditure(as % of GDP) of Sao Tome and Principe in 2006 to that in 2009?
Your response must be concise. 1.04. What is the ratio of the Expenditure(as % of GDP) in Brazil in 2006 to that in 2010?
Your answer should be compact. 0.94. What is the ratio of the Expenditure(as % of GDP) in Kyrgyz Republic in 2006 to that in 2010?
Give a very brief answer. 1.01. What is the ratio of the Expenditure(as % of GDP) in Luxembourg in 2006 to that in 2010?
Ensure brevity in your answer.  1.01. What is the ratio of the Expenditure(as % of GDP) in Sao Tome and Principe in 2006 to that in 2010?
Keep it short and to the point. 1.11. What is the ratio of the Expenditure(as % of GDP) in Brazil in 2006 to that in 2011?
Your response must be concise. 0.93. What is the ratio of the Expenditure(as % of GDP) of Kyrgyz Republic in 2006 to that in 2011?
Ensure brevity in your answer.  1.09. What is the ratio of the Expenditure(as % of GDP) in Luxembourg in 2006 to that in 2011?
Offer a very short reply. 1.05. What is the ratio of the Expenditure(as % of GDP) of Sao Tome and Principe in 2006 to that in 2011?
Your answer should be compact. 1.03. What is the ratio of the Expenditure(as % of GDP) of Brazil in 2007 to that in 2008?
Make the answer very short. 1. What is the ratio of the Expenditure(as % of GDP) of Kyrgyz Republic in 2007 to that in 2008?
Your answer should be very brief. 1.13. What is the ratio of the Expenditure(as % of GDP) in Luxembourg in 2007 to that in 2008?
Your response must be concise. 0.92. What is the ratio of the Expenditure(as % of GDP) of Sao Tome and Principe in 2007 to that in 2008?
Your response must be concise. 1.13. What is the ratio of the Expenditure(as % of GDP) of Brazil in 2007 to that in 2009?
Provide a succinct answer. 0.95. What is the ratio of the Expenditure(as % of GDP) of Kyrgyz Republic in 2007 to that in 2009?
Your answer should be compact. 1.01. What is the ratio of the Expenditure(as % of GDP) in Luxembourg in 2007 to that in 2009?
Offer a terse response. 0.83. What is the ratio of the Expenditure(as % of GDP) in Sao Tome and Principe in 2007 to that in 2009?
Provide a succinct answer. 0.95. What is the ratio of the Expenditure(as % of GDP) of Brazil in 2007 to that in 2010?
Keep it short and to the point. 0.94. What is the ratio of the Expenditure(as % of GDP) of Kyrgyz Republic in 2007 to that in 2010?
Give a very brief answer. 1.03. What is the ratio of the Expenditure(as % of GDP) in Luxembourg in 2007 to that in 2010?
Keep it short and to the point. 0.87. What is the ratio of the Expenditure(as % of GDP) of Sao Tome and Principe in 2007 to that in 2010?
Provide a short and direct response. 1.01. What is the ratio of the Expenditure(as % of GDP) in Brazil in 2007 to that in 2011?
Ensure brevity in your answer.  0.92. What is the ratio of the Expenditure(as % of GDP) of Kyrgyz Republic in 2007 to that in 2011?
Offer a terse response. 1.11. What is the ratio of the Expenditure(as % of GDP) of Luxembourg in 2007 to that in 2011?
Your answer should be compact. 0.91. What is the ratio of the Expenditure(as % of GDP) of Sao Tome and Principe in 2007 to that in 2011?
Offer a terse response. 0.94. What is the ratio of the Expenditure(as % of GDP) in Brazil in 2008 to that in 2009?
Provide a succinct answer. 0.95. What is the ratio of the Expenditure(as % of GDP) in Kyrgyz Republic in 2008 to that in 2009?
Offer a very short reply. 0.89. What is the ratio of the Expenditure(as % of GDP) in Luxembourg in 2008 to that in 2009?
Your response must be concise. 0.9. What is the ratio of the Expenditure(as % of GDP) of Sao Tome and Principe in 2008 to that in 2009?
Offer a very short reply. 0.84. What is the ratio of the Expenditure(as % of GDP) of Brazil in 2008 to that in 2010?
Offer a terse response. 0.94. What is the ratio of the Expenditure(as % of GDP) in Kyrgyz Republic in 2008 to that in 2010?
Offer a terse response. 0.91. What is the ratio of the Expenditure(as % of GDP) in Luxembourg in 2008 to that in 2010?
Keep it short and to the point. 0.96. What is the ratio of the Expenditure(as % of GDP) of Sao Tome and Principe in 2008 to that in 2010?
Give a very brief answer. 0.89. What is the ratio of the Expenditure(as % of GDP) of Brazil in 2008 to that in 2011?
Offer a terse response. 0.92. What is the ratio of the Expenditure(as % of GDP) in Kyrgyz Republic in 2008 to that in 2011?
Provide a succinct answer. 0.98. What is the ratio of the Expenditure(as % of GDP) of Luxembourg in 2008 to that in 2011?
Provide a succinct answer. 0.99. What is the ratio of the Expenditure(as % of GDP) in Sao Tome and Principe in 2008 to that in 2011?
Your response must be concise. 0.83. What is the ratio of the Expenditure(as % of GDP) of Brazil in 2009 to that in 2010?
Ensure brevity in your answer.  0.99. What is the ratio of the Expenditure(as % of GDP) of Kyrgyz Republic in 2009 to that in 2010?
Provide a succinct answer. 1.02. What is the ratio of the Expenditure(as % of GDP) in Luxembourg in 2009 to that in 2010?
Keep it short and to the point. 1.06. What is the ratio of the Expenditure(as % of GDP) of Brazil in 2009 to that in 2011?
Provide a short and direct response. 0.97. What is the ratio of the Expenditure(as % of GDP) in Kyrgyz Republic in 2009 to that in 2011?
Provide a short and direct response. 1.1. What is the ratio of the Expenditure(as % of GDP) of Luxembourg in 2009 to that in 2011?
Your answer should be very brief. 1.1. What is the ratio of the Expenditure(as % of GDP) of Sao Tome and Principe in 2009 to that in 2011?
Provide a succinct answer. 0.99. What is the ratio of the Expenditure(as % of GDP) in Brazil in 2010 to that in 2011?
Keep it short and to the point. 0.98. What is the ratio of the Expenditure(as % of GDP) of Kyrgyz Republic in 2010 to that in 2011?
Your answer should be very brief. 1.08. What is the ratio of the Expenditure(as % of GDP) of Luxembourg in 2010 to that in 2011?
Your answer should be compact. 1.04. What is the ratio of the Expenditure(as % of GDP) of Sao Tome and Principe in 2010 to that in 2011?
Your answer should be very brief. 0.93. What is the difference between the highest and the second highest Expenditure(as % of GDP) of Brazil?
Offer a very short reply. 0.17. What is the difference between the highest and the second highest Expenditure(as % of GDP) of Kyrgyz Republic?
Provide a short and direct response. 0.08. What is the difference between the highest and the second highest Expenditure(as % of GDP) in Luxembourg?
Your answer should be very brief. 0.17. What is the difference between the highest and the second highest Expenditure(as % of GDP) of Sao Tome and Principe?
Offer a very short reply. 2.16. What is the difference between the highest and the lowest Expenditure(as % of GDP) of Brazil?
Your answer should be very brief. 0.81. What is the difference between the highest and the lowest Expenditure(as % of GDP) of Kyrgyz Republic?
Provide a short and direct response. 1.05. What is the difference between the highest and the lowest Expenditure(as % of GDP) in Luxembourg?
Offer a terse response. 1.4. What is the difference between the highest and the lowest Expenditure(as % of GDP) in Sao Tome and Principe?
Your answer should be compact. 3.71. 